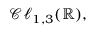<formula> <loc_0><loc_0><loc_500><loc_500>{ \mathcal { C l } } _ { 1 , 3 } ( \mathbb { R } ) ,</formula> 